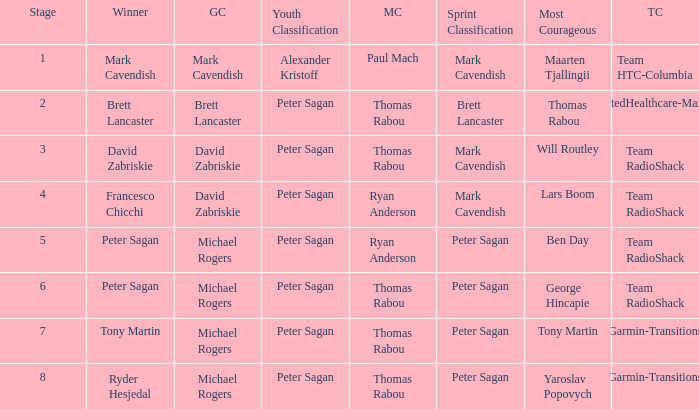When Ryan Anderson won the mountains classification, and Michael Rogers won the general classification, who won the sprint classification? Peter Sagan. 